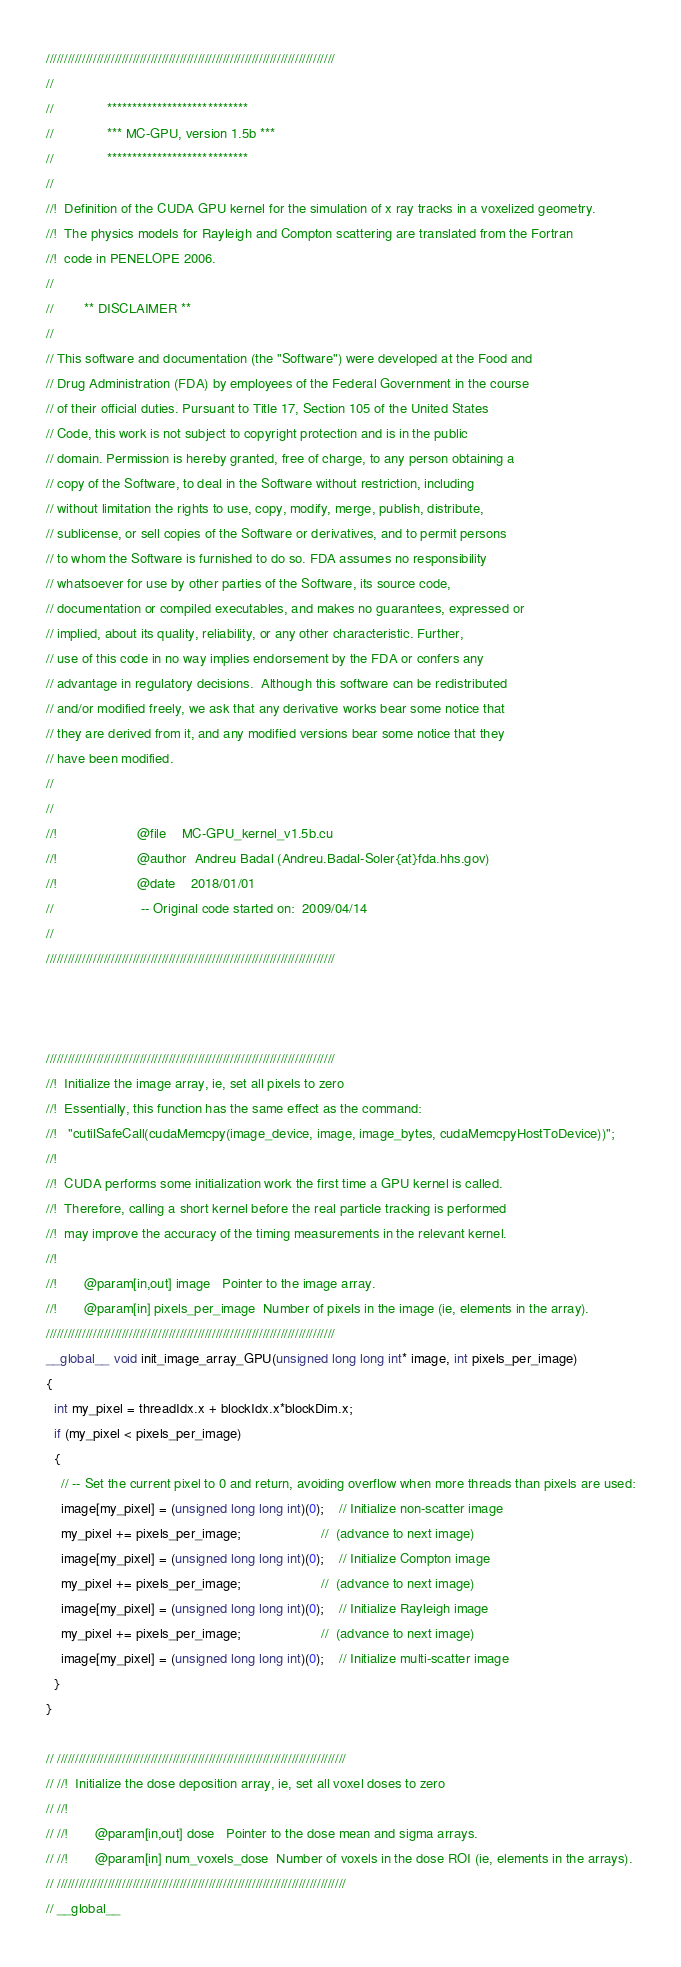Convert code to text. <code><loc_0><loc_0><loc_500><loc_500><_Cuda_>
////////////////////////////////////////////////////////////////////////////////
//
//              ****************************
//              *** MC-GPU, version 1.5b ***
//              ****************************
//                                          
//!  Definition of the CUDA GPU kernel for the simulation of x ray tracks in a voxelized geometry.
//!  The physics models for Rayleigh and Compton scattering are translated from the Fortran
//!  code in PENELOPE 2006.
//
//        ** DISCLAIMER **
//
// This software and documentation (the "Software") were developed at the Food and
// Drug Administration (FDA) by employees of the Federal Government in the course
// of their official duties. Pursuant to Title 17, Section 105 of the United States
// Code, this work is not subject to copyright protection and is in the public
// domain. Permission is hereby granted, free of charge, to any person obtaining a
// copy of the Software, to deal in the Software without restriction, including
// without limitation the rights to use, copy, modify, merge, publish, distribute,
// sublicense, or sell copies of the Software or derivatives, and to permit persons
// to whom the Software is furnished to do so. FDA assumes no responsibility
// whatsoever for use by other parties of the Software, its source code,
// documentation or compiled executables, and makes no guarantees, expressed or
// implied, about its quality, reliability, or any other characteristic. Further,
// use of this code in no way implies endorsement by the FDA or confers any
// advantage in regulatory decisions.  Although this software can be redistributed
// and/or modified freely, we ask that any derivative works bear some notice that
// they are derived from it, and any modified versions bear some notice that they
// have been modified.
//                                                                            
//
//!                     @file    MC-GPU_kernel_v1.5b.cu
//!                     @author  Andreu Badal (Andreu.Badal-Soler{at}fda.hhs.gov)
//!                     @date    2018/01/01
//                       -- Original code started on:  2009/04/14
//
////////////////////////////////////////////////////////////////////////////////



////////////////////////////////////////////////////////////////////////////////
//!  Initialize the image array, ie, set all pixels to zero
//!  Essentially, this function has the same effect as the command: 
//!   "cutilSafeCall(cudaMemcpy(image_device, image, image_bytes, cudaMemcpyHostToDevice))";
//!  
//!  CUDA performs some initialization work the first time a GPU kernel is called.
//!  Therefore, calling a short kernel before the real particle tracking is performed
//!  may improve the accuracy of the timing measurements in the relevant kernel.
//!  
//!       @param[in,out] image   Pointer to the image array.
//!       @param[in] pixels_per_image  Number of pixels in the image (ie, elements in the array).
////////////////////////////////////////////////////////////////////////////////
__global__ void init_image_array_GPU(unsigned long long int* image, int pixels_per_image)
{
  int my_pixel = threadIdx.x + blockIdx.x*blockDim.x;
  if (my_pixel < pixels_per_image)
  {
    // -- Set the current pixel to 0 and return, avoiding overflow when more threads than pixels are used:
    image[my_pixel] = (unsigned long long int)(0);    // Initialize non-scatter image
    my_pixel += pixels_per_image;                     //  (advance to next image)
    image[my_pixel] = (unsigned long long int)(0);    // Initialize Compton image
    my_pixel += pixels_per_image;                     //  (advance to next image)
    image[my_pixel] = (unsigned long long int)(0);    // Initialize Rayleigh image
    my_pixel += pixels_per_image;                     //  (advance to next image)
    image[my_pixel] = (unsigned long long int)(0);    // Initialize multi-scatter image
  }
}

// ////////////////////////////////////////////////////////////////////////////////
// //!  Initialize the dose deposition array, ie, set all voxel doses to zero
// //!  
// //!       @param[in,out] dose   Pointer to the dose mean and sigma arrays.
// //!       @param[in] num_voxels_dose  Number of voxels in the dose ROI (ie, elements in the arrays).
// ////////////////////////////////////////////////////////////////////////////////
// __global__</code> 